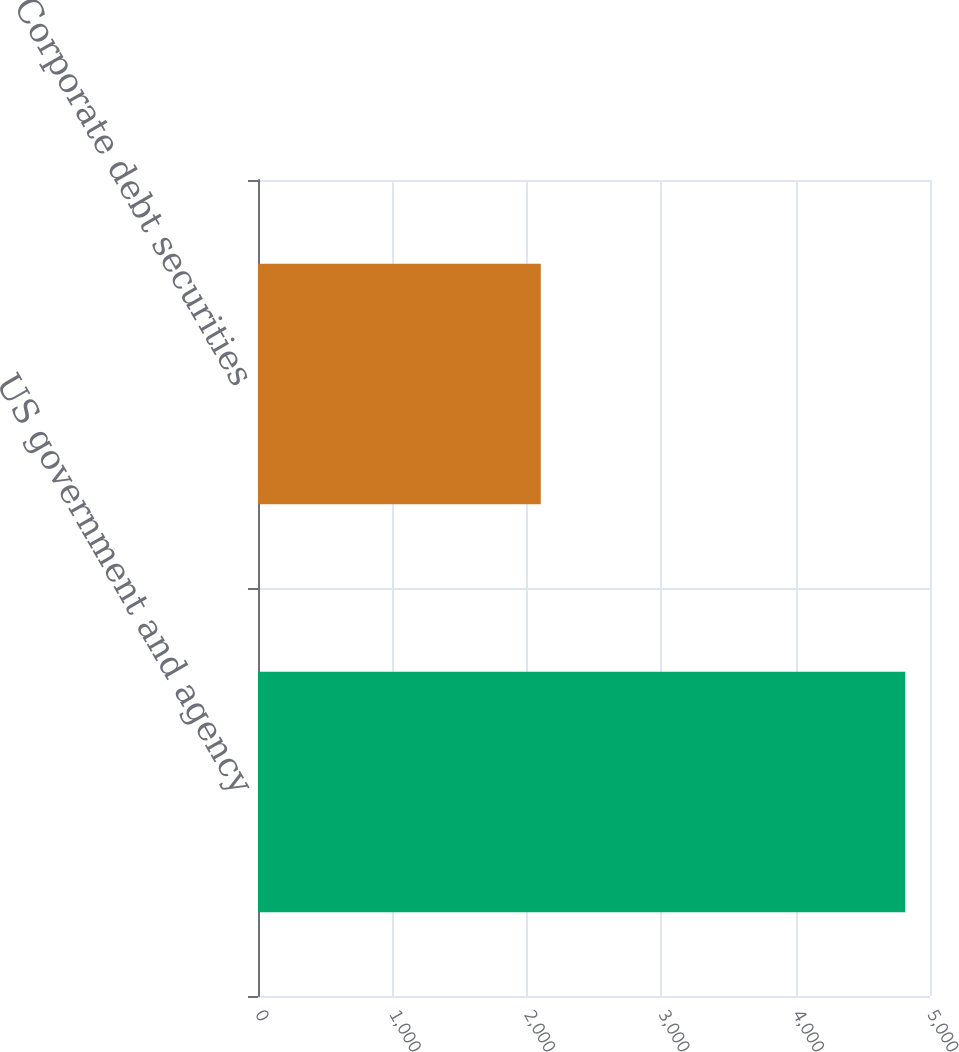Convert chart. <chart><loc_0><loc_0><loc_500><loc_500><bar_chart><fcel>US government and agency<fcel>Corporate debt securities<nl><fcel>4816<fcel>2104<nl></chart> 